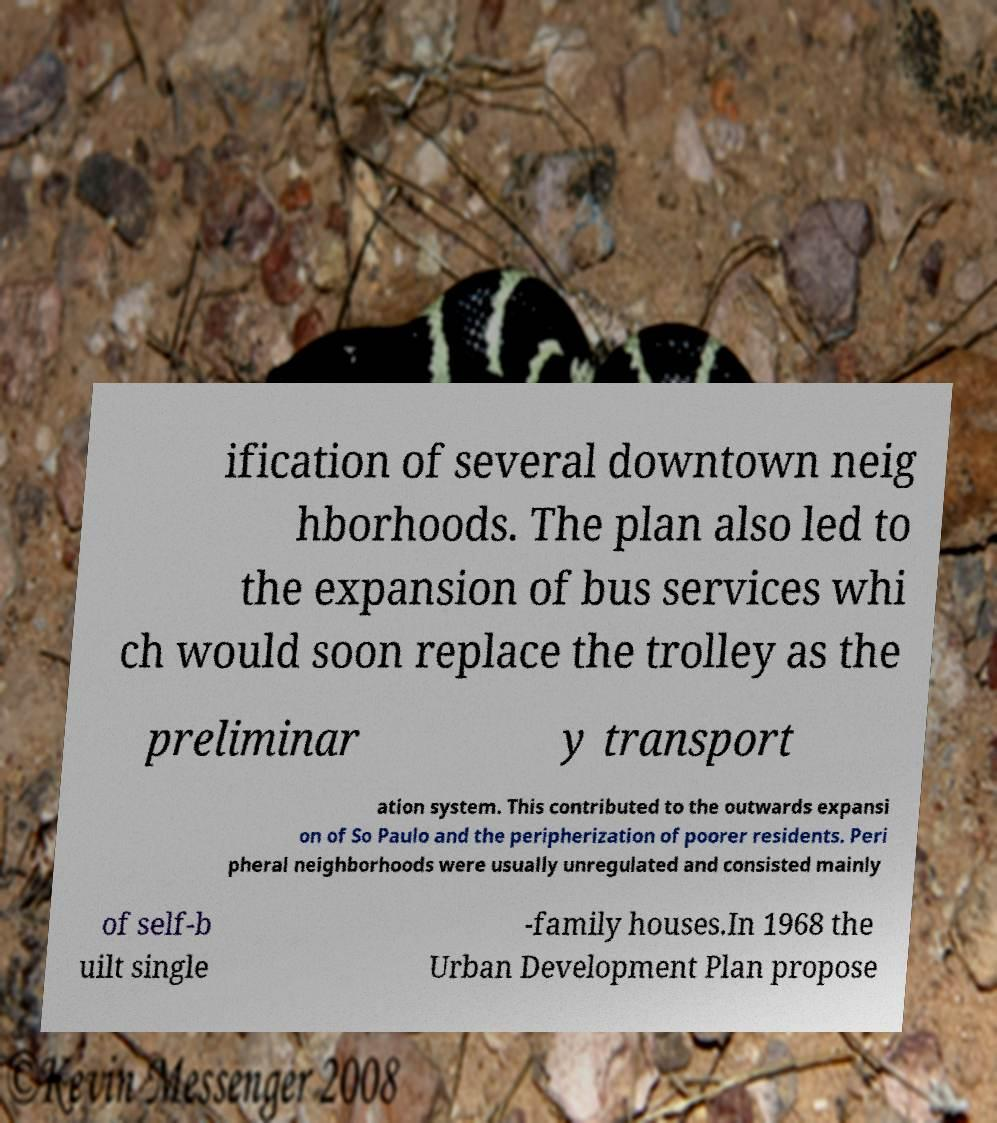What messages or text are displayed in this image? I need them in a readable, typed format. ification of several downtown neig hborhoods. The plan also led to the expansion of bus services whi ch would soon replace the trolley as the preliminar y transport ation system. This contributed to the outwards expansi on of So Paulo and the peripherization of poorer residents. Peri pheral neighborhoods were usually unregulated and consisted mainly of self-b uilt single -family houses.In 1968 the Urban Development Plan propose 